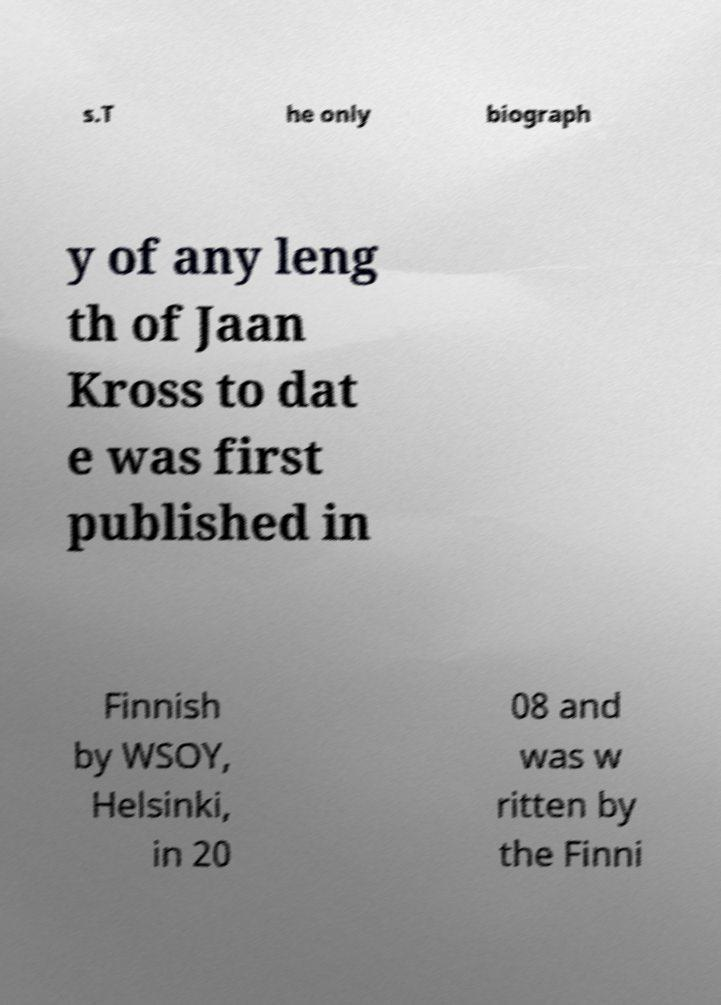Can you read and provide the text displayed in the image?This photo seems to have some interesting text. Can you extract and type it out for me? s.T he only biograph y of any leng th of Jaan Kross to dat e was first published in Finnish by WSOY, Helsinki, in 20 08 and was w ritten by the Finni 